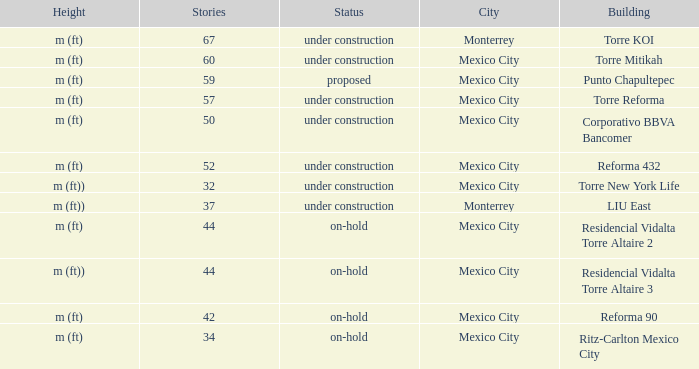How many stories is the torre reforma building? 1.0. 